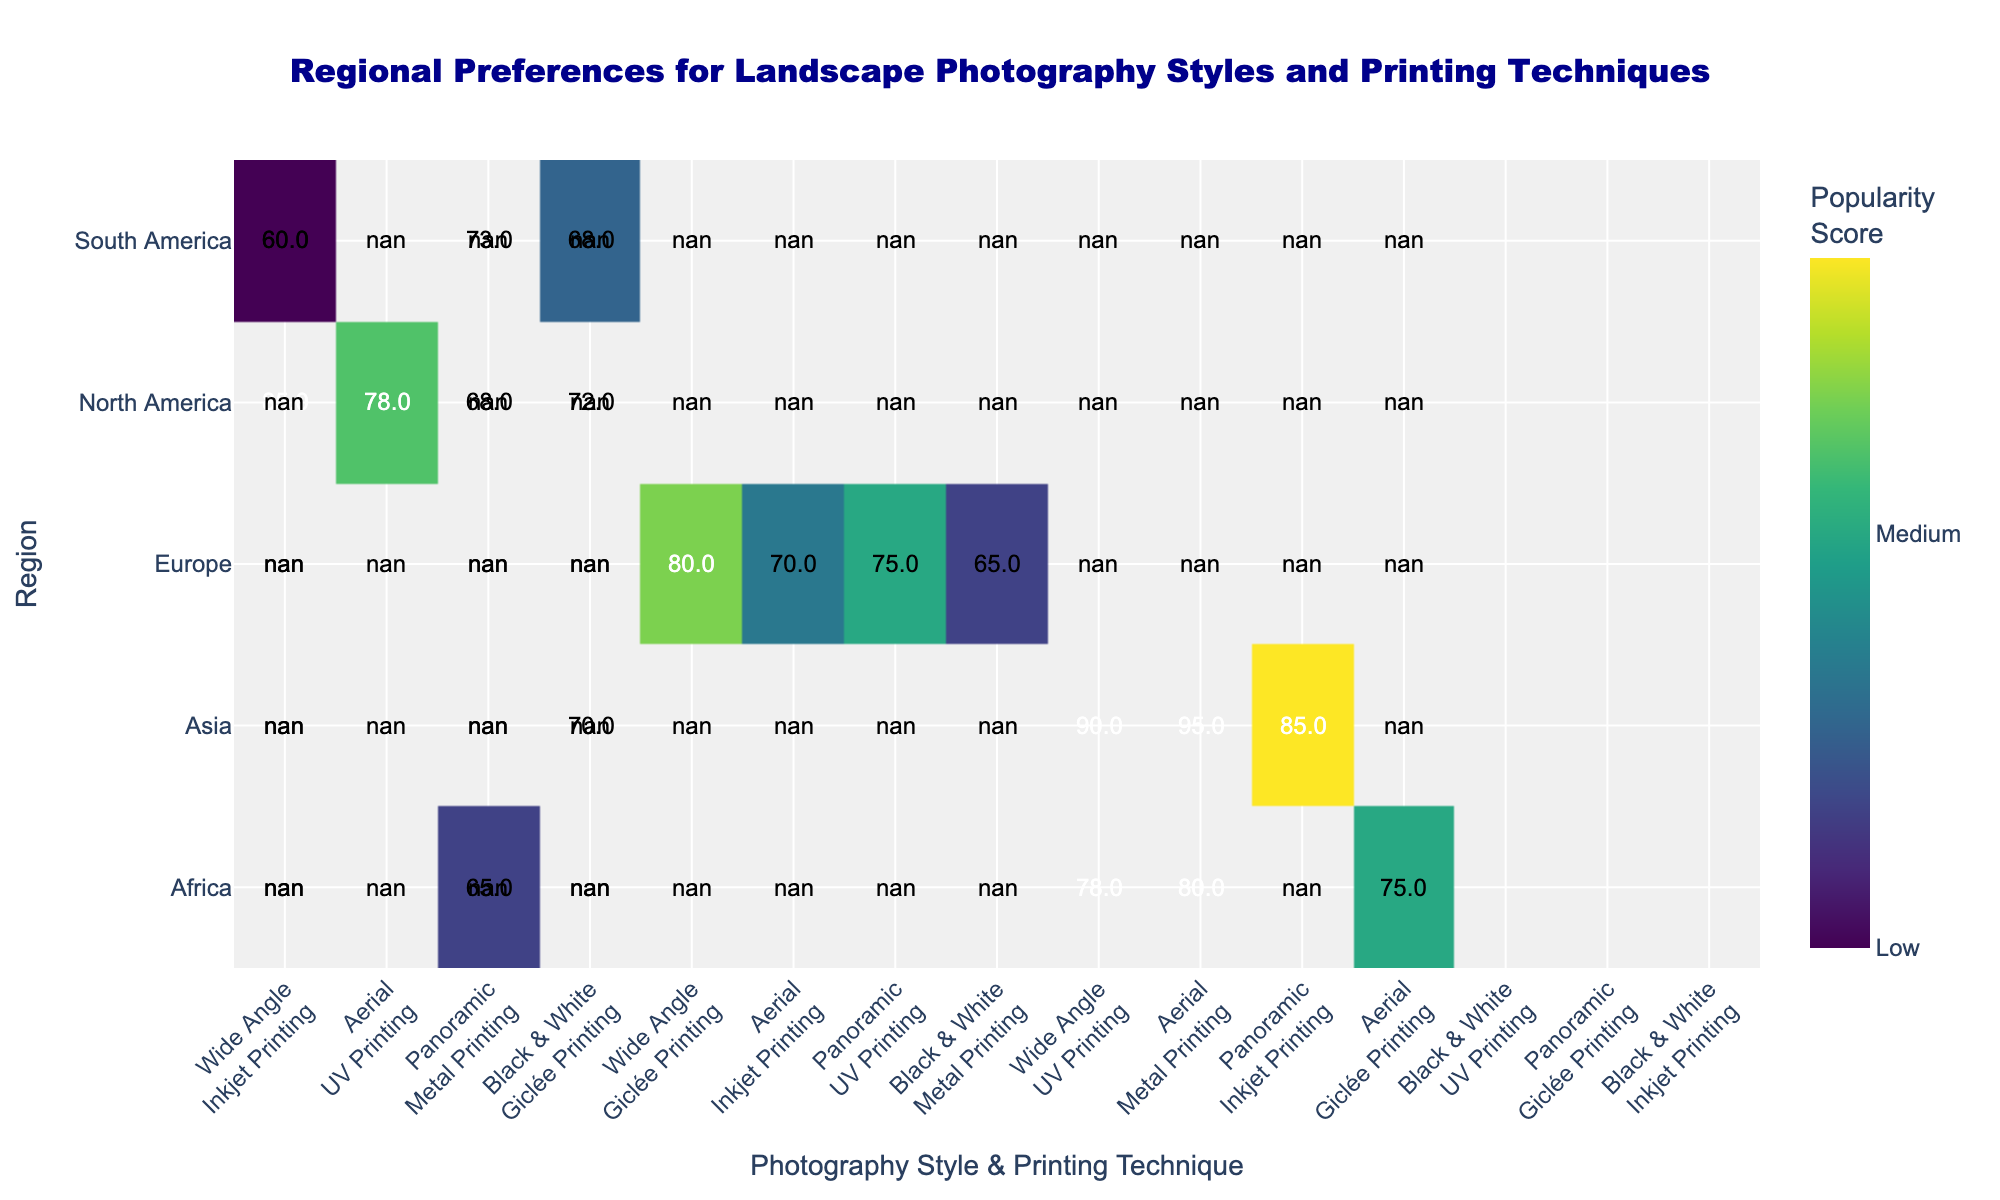Which region has the highest popularity score for Aerial photography? Look through the heatmap to find the highest score for Aerial photography for each region, then identify the region with the highest score. Asia has Aerial photography with a popularity score of 95.
Answer: Asia What is the title of the heatmap? The title of the heatmap is typically stated at the top of the figure.
Answer: Regional Preferences for Landscape Photography Styles and Printing Techniques Which photography style and printing technique combination has the lowest popularity score in Europe? Examine the relevant section for Europe in the heatmap and identify the photography style and printing technique pair with the lowest popularity score. Europe has Black & White photography with Metal Printing at the lowest score of 65.
Answer: Black & White, Metal Printing How many regions have a popularity score for Wide Angle photography above 80? Look at each region’s scores for Wide Angle photography and count those that are above 80. North America (85), Europe (80), and Asia (90) satisfy this condition.
Answer: 3 Which region prefers Metal Printing techniques the most? Find the region with the highest popularity score for any photography style associated with Metal Printing. Asia has the highest score with 95 for Aerial photography.
Answer: Asia What is the average popularity score for Panoramic photography across all regions? Identify the popularity scores for Panoramic photography across all regions, sum them up and then divide by the number of regions. The scores are: North America (68), Europe (75), Asia (85), South America (73), and Africa (75), sum is 376. Average is 376/5 = 75.2.
Answer: 75.2 Which region shows equal popularity score for both UV Printing and Metal Printing techniques? Analyze the popularity scores for UV Printing and Metal Printing for each region to find any equal scores. In Africa, Wide Angle (78) with UV Printing and Aerial (80) with Metal Printing. None match precisely, so no region has equal scores.
Answer: None Is UV Printing more popular in North America or South America? Compare the UV Printing popularity scores in North America and South America. North America has UV Printing score of 78 for Aerial while South America has UV Printing score of 60 for Black & White.
Answer: North America Which region has the most diverse preferences in terms of photography styles? Determine the range of popularity scores for each region across all photography styles and printing techniques, then identify the region with the largest range. North America ranges from 68 to 85 (17), Europe from 65 to 80 (15), Asia from 70 to 95 (25), South America from 60 to 73 (13), Africa from 65 to 80 (15). Asia has the highest range of scores.
Answer: Asia 